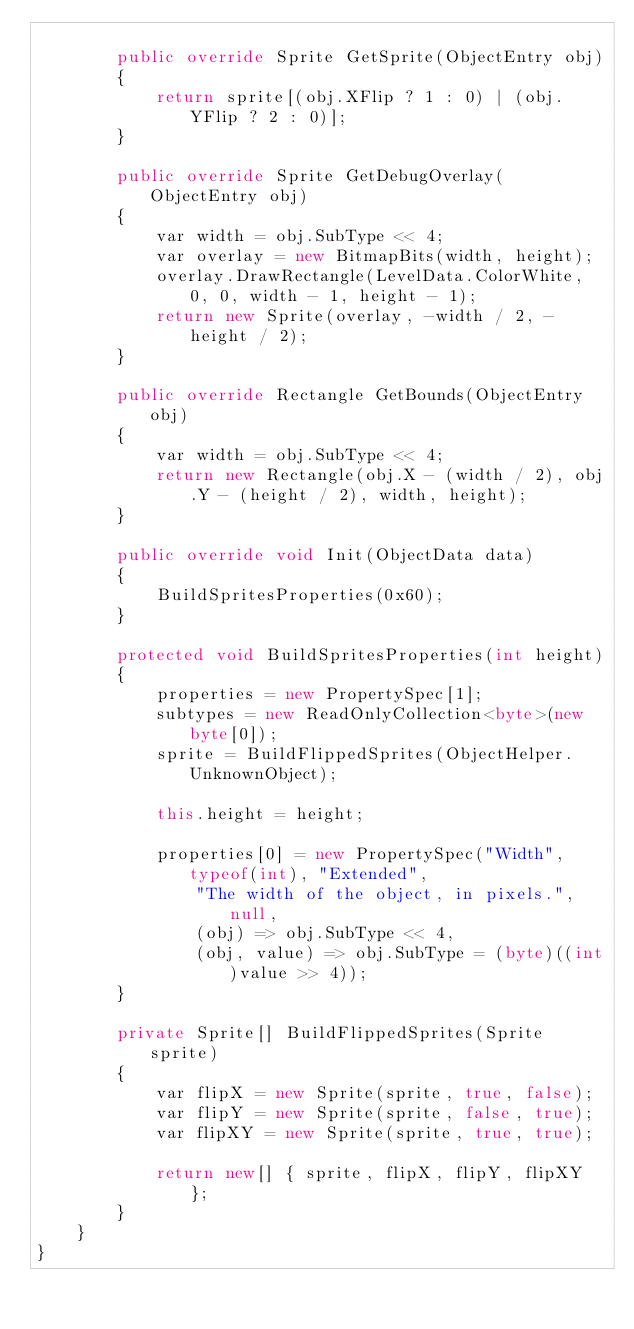<code> <loc_0><loc_0><loc_500><loc_500><_C#_>
		public override Sprite GetSprite(ObjectEntry obj)
		{
			return sprite[(obj.XFlip ? 1 : 0) | (obj.YFlip ? 2 : 0)];
		}

		public override Sprite GetDebugOverlay(ObjectEntry obj)
		{
			var width = obj.SubType << 4;
			var overlay = new BitmapBits(width, height);
			overlay.DrawRectangle(LevelData.ColorWhite, 0, 0, width - 1, height - 1);
			return new Sprite(overlay, -width / 2, -height / 2);
		}

		public override Rectangle GetBounds(ObjectEntry obj)
		{
			var width = obj.SubType << 4;
			return new Rectangle(obj.X - (width / 2), obj.Y - (height / 2), width, height);
		}

		public override void Init(ObjectData data)
		{
			BuildSpritesProperties(0x60);
		}

		protected void BuildSpritesProperties(int height)
		{
			properties = new PropertySpec[1];
			subtypes = new ReadOnlyCollection<byte>(new byte[0]);
			sprite = BuildFlippedSprites(ObjectHelper.UnknownObject);

			this.height = height;

			properties[0] = new PropertySpec("Width", typeof(int), "Extended",
				"The width of the object, in pixels.", null,
				(obj) => obj.SubType << 4,
				(obj, value) => obj.SubType = (byte)((int)value >> 4));
		}

		private Sprite[] BuildFlippedSprites(Sprite sprite)
		{
			var flipX = new Sprite(sprite, true, false);
			var flipY = new Sprite(sprite, false, true);
			var flipXY = new Sprite(sprite, true, true);

			return new[] { sprite, flipX, flipY, flipXY };
		}
	}
}
</code> 